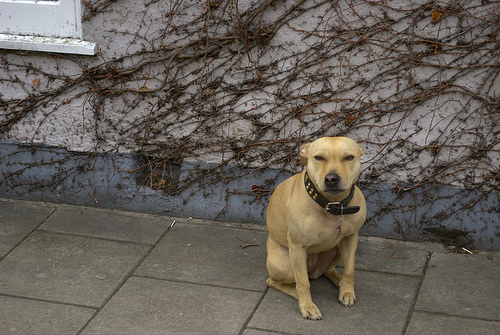Is this type of dog suitable for families? Yes, this breed of dog is often considered ideal for families due to their loyal, gentle, and friendly temperament. They're known to be good with children and adapt well to family life. 